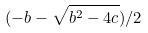Convert formula to latex. <formula><loc_0><loc_0><loc_500><loc_500>( - b - \sqrt { b ^ { 2 } - 4 c } ) / 2</formula> 